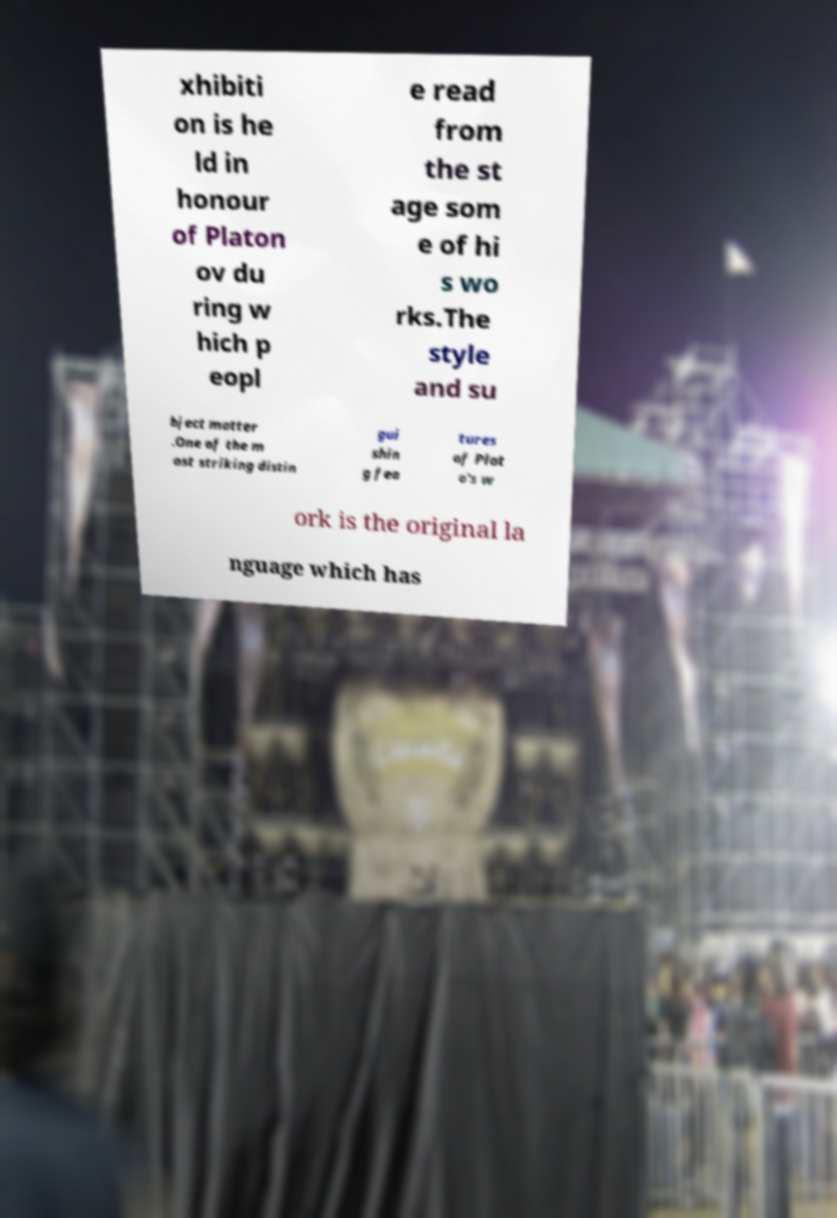Can you accurately transcribe the text from the provided image for me? xhibiti on is he ld in honour of Platon ov du ring w hich p eopl e read from the st age som e of hi s wo rks.The style and su bject matter .One of the m ost striking distin gui shin g fea tures of Plat o's w ork is the original la nguage which has 